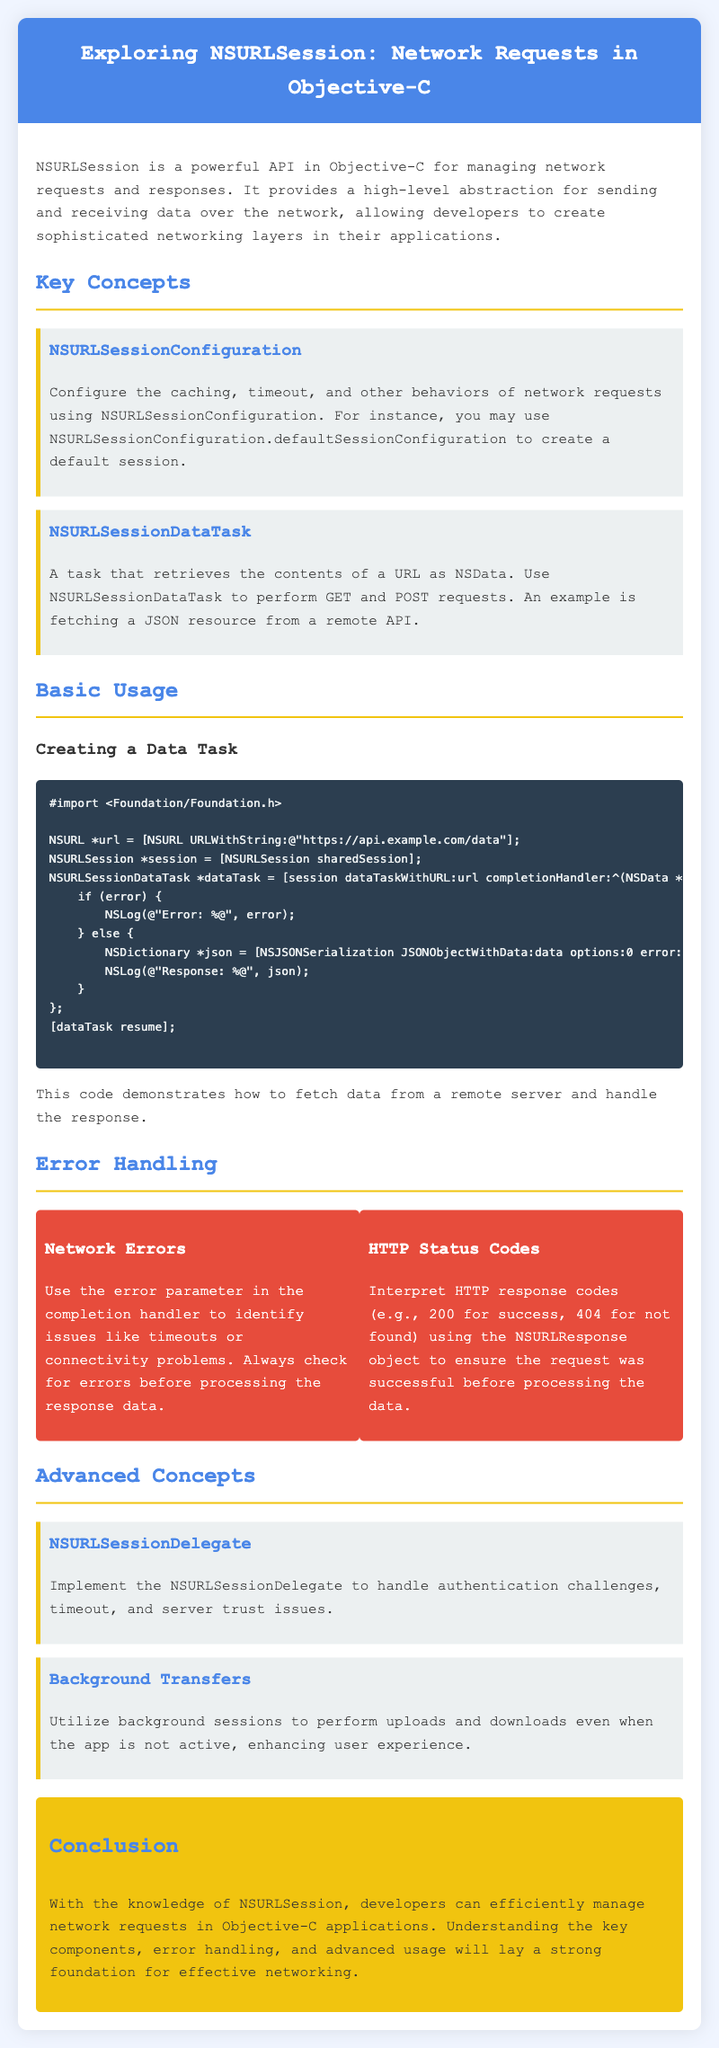What is the main purpose of NSURLSession? The main purpose is to manage network requests and responses efficiently, providing a high-level abstraction for sending and receiving data over the network.
Answer: Manage network requests and responses What method is used to create a default session configuration? The document states the method to create a default session configuration is by using NSURLSessionConfiguration.defaultSessionConfiguration.
Answer: defaultSessionConfiguration What type of task retrieves the contents of a URL as NSData? The document refers to this type of task as NSURLSessionDataTask.
Answer: NSURLSessionDataTask Which object should be checked to interpret HTTP response codes? The document indicates that the NSURLResponse object should be checked to interpret HTTP response codes.
Answer: NSURLResponse What should be implemented to handle authentication challenges? The document states that NSURLSessionDelegate should be implemented to handle authentication challenges.
Answer: NSURLSessionDelegate What is a benefit of utilizing background sessions? The benefit mentioned in the document is that they allow uploads and downloads even when the app is not active.
Answer: User experience How should network errors be handled according to the document? The document suggests using the error parameter in the completion handler to identify network errors.
Answer: Error parameter What is the primary use of NSURLSessionDataTask? The document describes its primary use as performing GET and POST requests.
Answer: GET and POST requests What color is used for the primary theme in the document? The primary theme color specified in the document is #4a86e8.
Answer: #4a86e8 